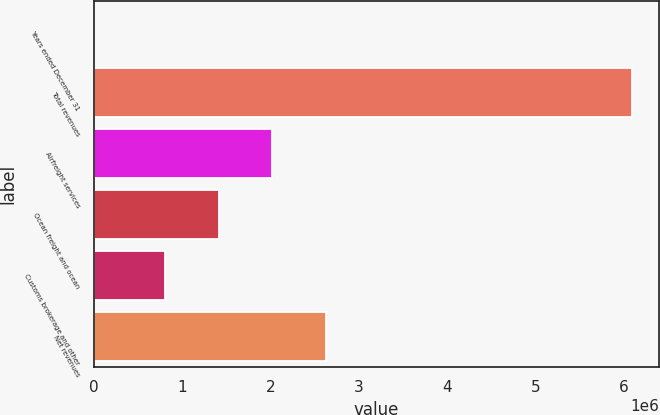Convert chart. <chart><loc_0><loc_0><loc_500><loc_500><bar_chart><fcel>Years ended December 31<fcel>Total revenues<fcel>Airfreight services<fcel>Ocean freight and ocean<fcel>Customs brokerage and other<fcel>Net revenues<nl><fcel>2016<fcel>6.09804e+06<fcel>2.02234e+06<fcel>1.41274e+06<fcel>803135<fcel>2.63194e+06<nl></chart> 